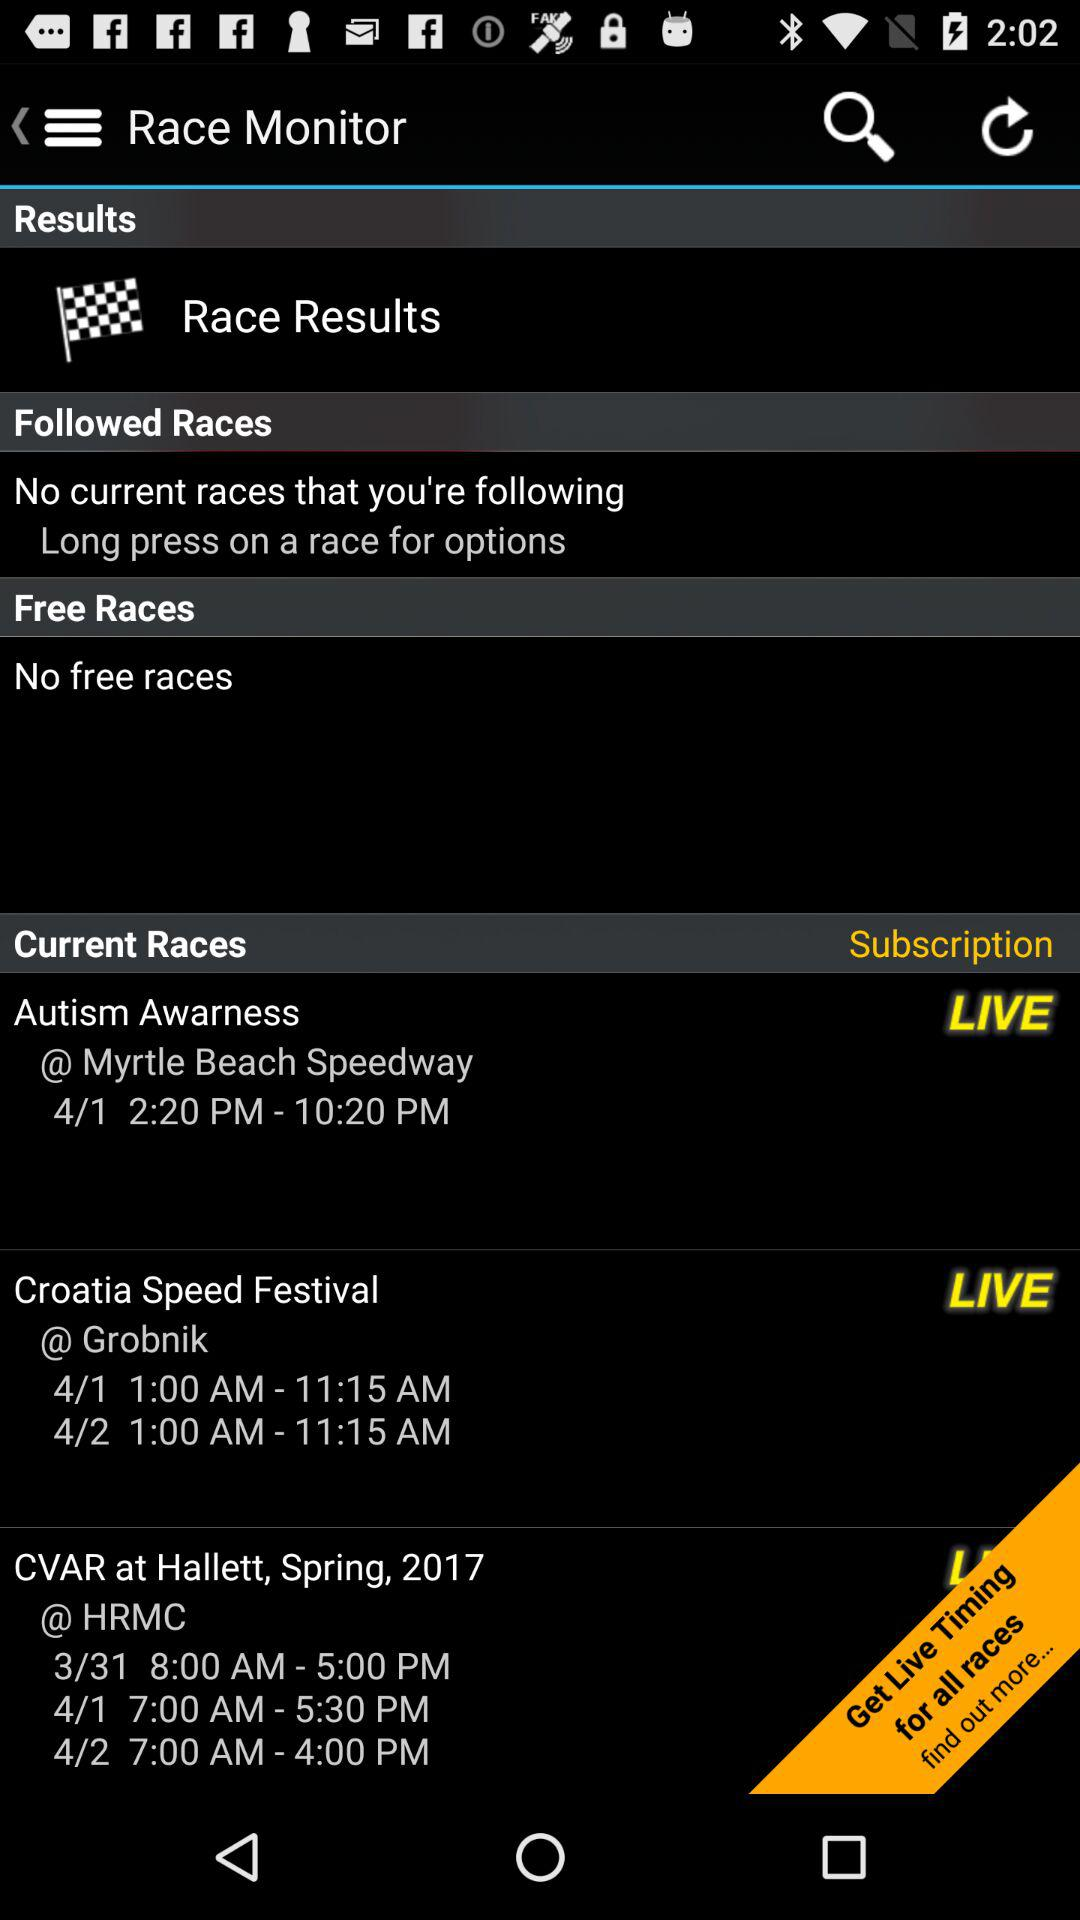Can you tell me more about the 'Subscription' option in the app? The 'Subscription' option likely refers to a premium service offered by the app, providing additional features such as live timing for all listed races, as suggested by the 'Get Live Timing for all races' call-to-action button. 